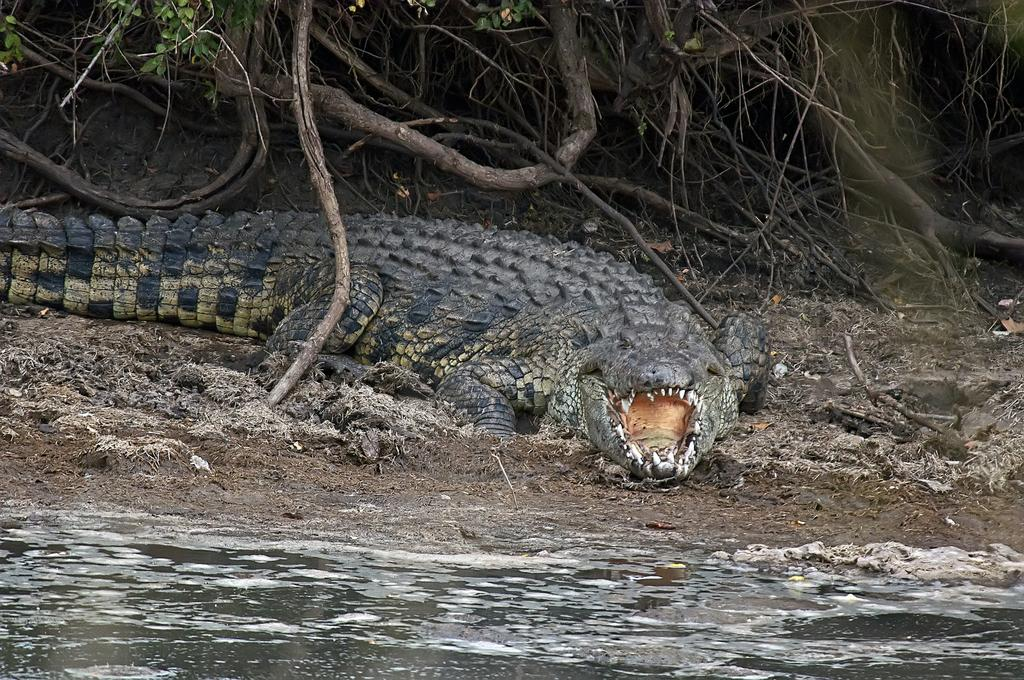What animal can be seen on the ground in the image? There is a crocodile on the ground in the image. What type of environment is depicted in the image? There is water visible at the bottom of the image, suggesting a wet or aquatic environment. What can be seen in the background of the image? There are many sticks in the background of the image. What type of transport is being used by the fireman in the image? There is no fireman or transport present in the image. 